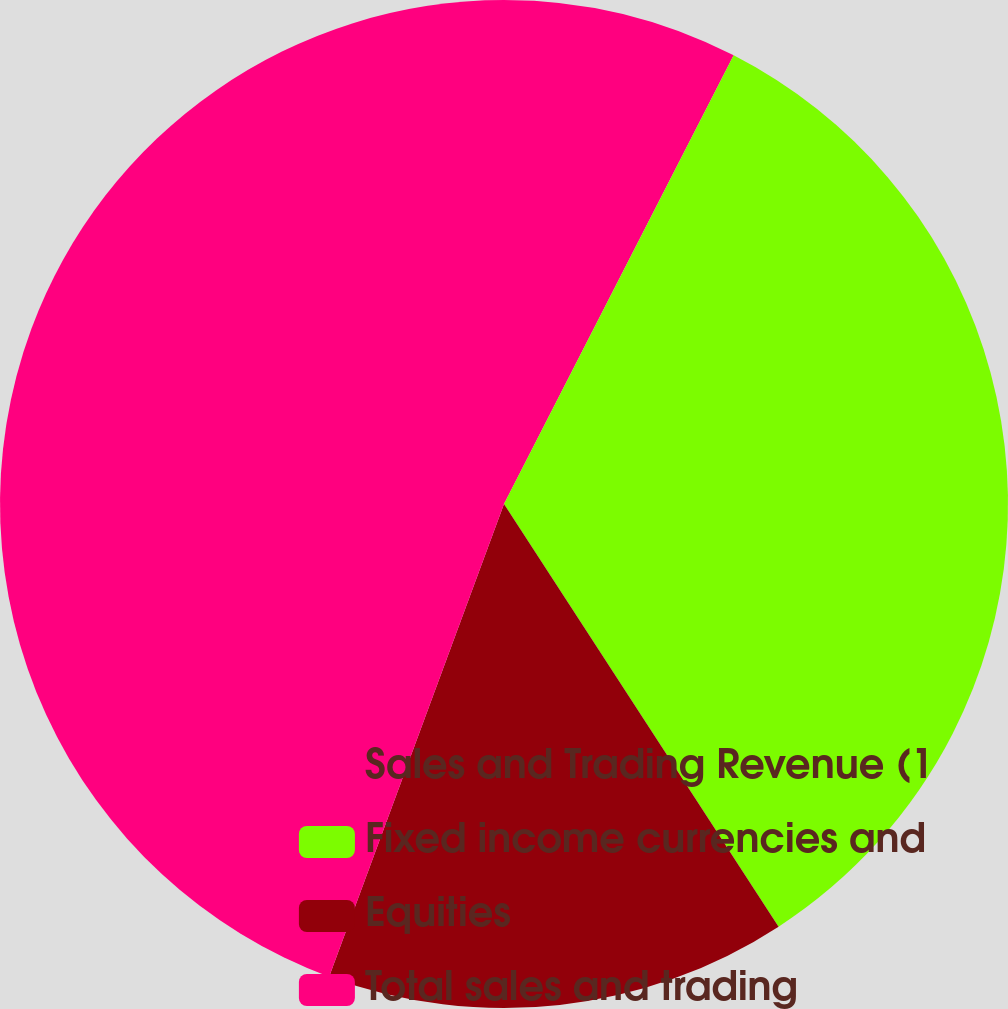Convert chart to OTSL. <chart><loc_0><loc_0><loc_500><loc_500><pie_chart><fcel>Sales and Trading Revenue (1<fcel>Fixed income currencies and<fcel>Equities<fcel>Total sales and trading<nl><fcel>7.53%<fcel>33.3%<fcel>14.81%<fcel>44.36%<nl></chart> 